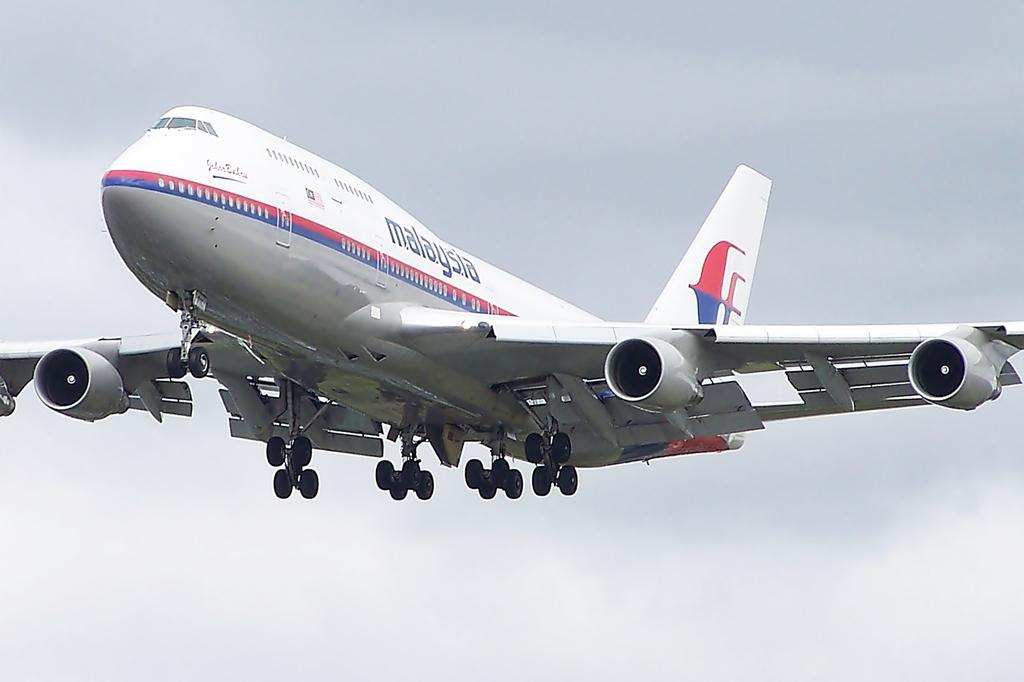What is the main subject of the picture? The main subject of the picture is an airplane. What is the airplane doing in the picture? The airplane is flying in the sky. What type of cake is the queen eating in the image? There is no cake or queen present in the image; it only features an airplane flying in the sky. 